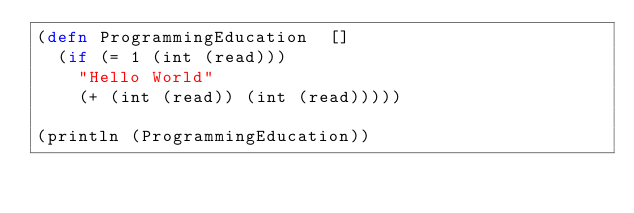Convert code to text. <code><loc_0><loc_0><loc_500><loc_500><_Clojure_>(defn ProgrammingEducation  []
  (if (= 1 (int (read)))
    "Hello World"
    (+ (int (read)) (int (read)))))

(println (ProgrammingEducation))</code> 